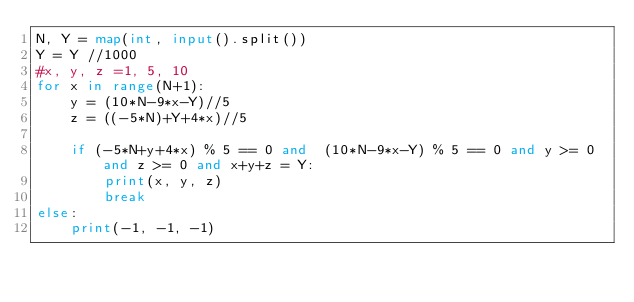Convert code to text. <code><loc_0><loc_0><loc_500><loc_500><_Python_>N, Y = map(int, input().split())
Y = Y //1000
#x, y, z =1, 5, 10
for x in range(N+1):
    y = (10*N-9*x-Y)//5
    z = ((-5*N)+Y+4*x)//5
    
    if (-5*N+y+4*x) % 5 == 0 and  (10*N-9*x-Y) % 5 == 0 and y >= 0 and z >= 0 and x+y+z = Y:
        print(x, y, z)
        break
else:
    print(-1, -1, -1)</code> 